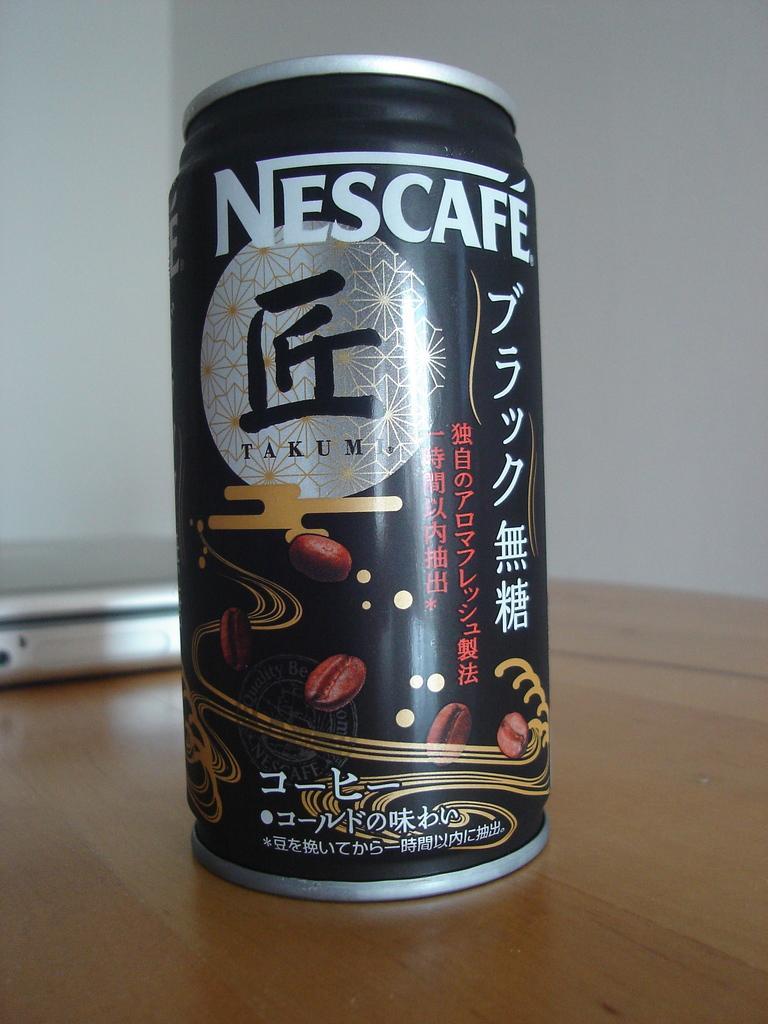Can you describe this image briefly? In this image we can see a tin and a device which are placed on the table. On the backside we can see a wall. 